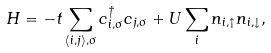<formula> <loc_0><loc_0><loc_500><loc_500>H = - t \sum _ { \langle i , j \rangle , \sigma } c ^ { \dag } _ { i , \sigma } c _ { j , \sigma } + U \sum _ { i } n _ { i , \uparrow } n _ { i , \downarrow } ,</formula> 